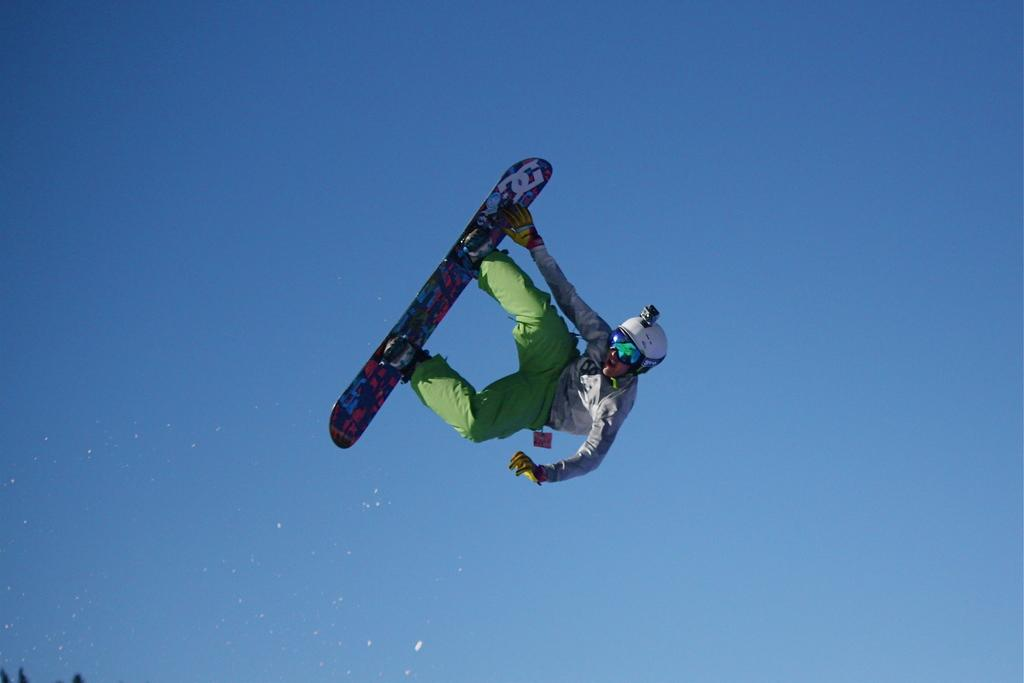What is the main subject of the image? The main subject of the image is a man. What protective gear is the man wearing? The man is wearing a helmet, goggles, and gloves. What is the man standing on in the image? The man is standing on a skateboard. What is the man doing in the image? The man is in the air, suggesting he is performing a skateboard trick. What can be seen in the background of the image? The sky is visible in the background of the image. What type of son can be heard in the background of the image? There is no sound present in the image, so it is not possible to determine if any type of son can be heard. 